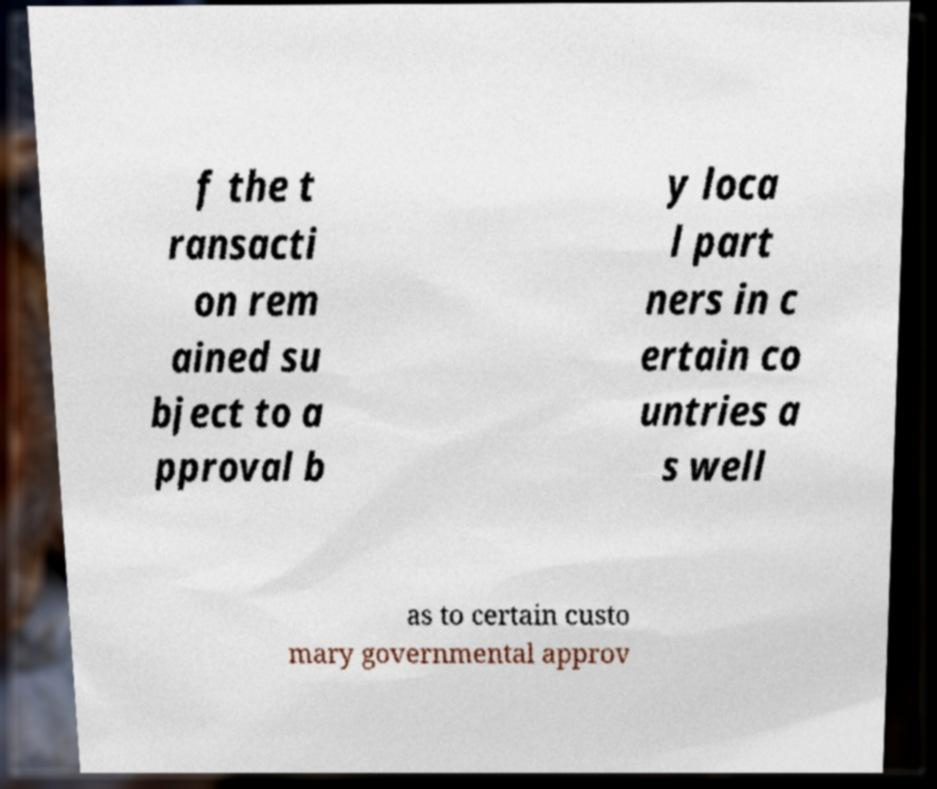Can you read and provide the text displayed in the image?This photo seems to have some interesting text. Can you extract and type it out for me? f the t ransacti on rem ained su bject to a pproval b y loca l part ners in c ertain co untries a s well as to certain custo mary governmental approv 